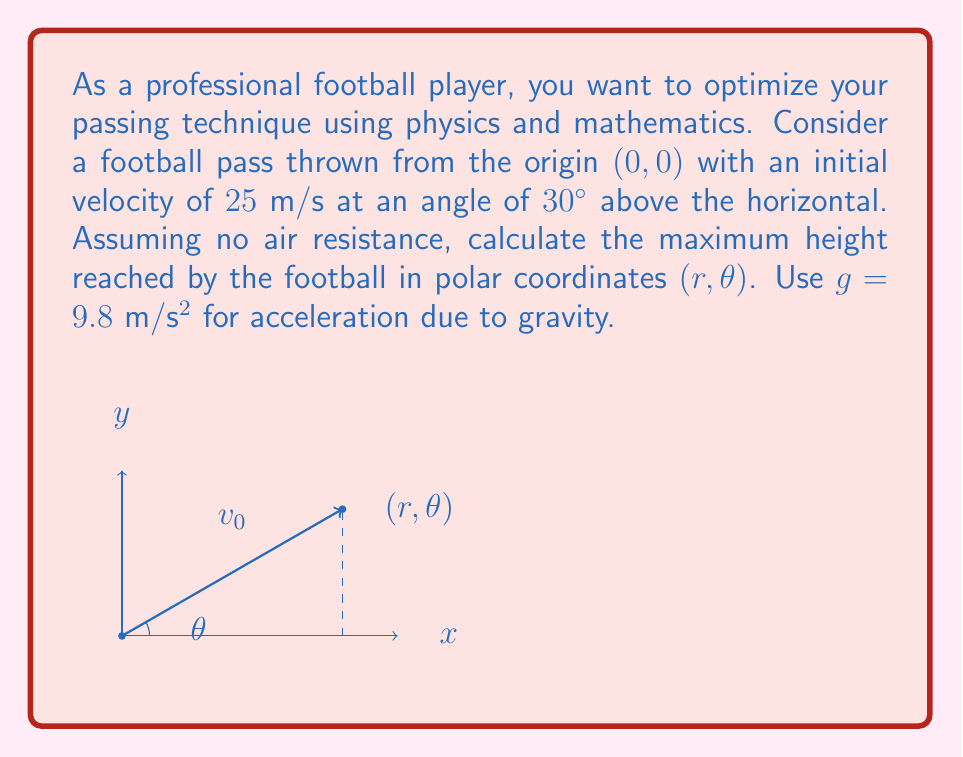Help me with this question. Let's approach this step-by-step:

1) First, we need to find the time at which the football reaches its maximum height. At this point, the vertical velocity is zero:

   $v_y = v_0 \sin \theta - gt = 0$
   $t_{max} = \frac{v_0 \sin \theta}{g}$

2) Substitute the given values:

   $t_{max} = \frac{25 \sin 30°}{9.8} = \frac{25 \cdot 0.5}{9.8} \approx 1.276$ seconds

3) Now we can calculate the x and y coordinates at the maximum height:

   $x = v_0 \cos \theta \cdot t_{max} = 25 \cos 30° \cdot 1.276 \approx 27.65$ m
   $y = v_0 \sin \theta \cdot t_{max} - \frac{1}{2}gt_{max}^2 = 25 \sin 30° \cdot 1.276 - \frac{1}{2} \cdot 9.8 \cdot 1.276^2 \approx 7.97$ m

4) To convert to polar coordinates, we use:

   $r = \sqrt{x^2 + y^2}$
   $\theta = \arctan(\frac{y}{x})$

5) Calculating r:

   $r = \sqrt{27.65^2 + 7.97^2} \approx 28.75$ m

6) Calculating θ:

   $\theta = \arctan(\frac{7.97}{27.65}) \approx 0.2808$ radians or $16.09°$

Therefore, in polar coordinates, the football reaches its maximum height at approximately (28.75 m, 16.09°).
Answer: $$(28.75 \text{ m}, 16.09°)$$ 